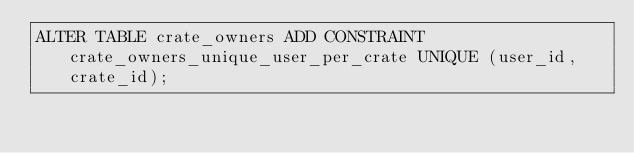Convert code to text. <code><loc_0><loc_0><loc_500><loc_500><_SQL_>ALTER TABLE crate_owners ADD CONSTRAINT crate_owners_unique_user_per_crate UNIQUE (user_id, crate_id);</code> 